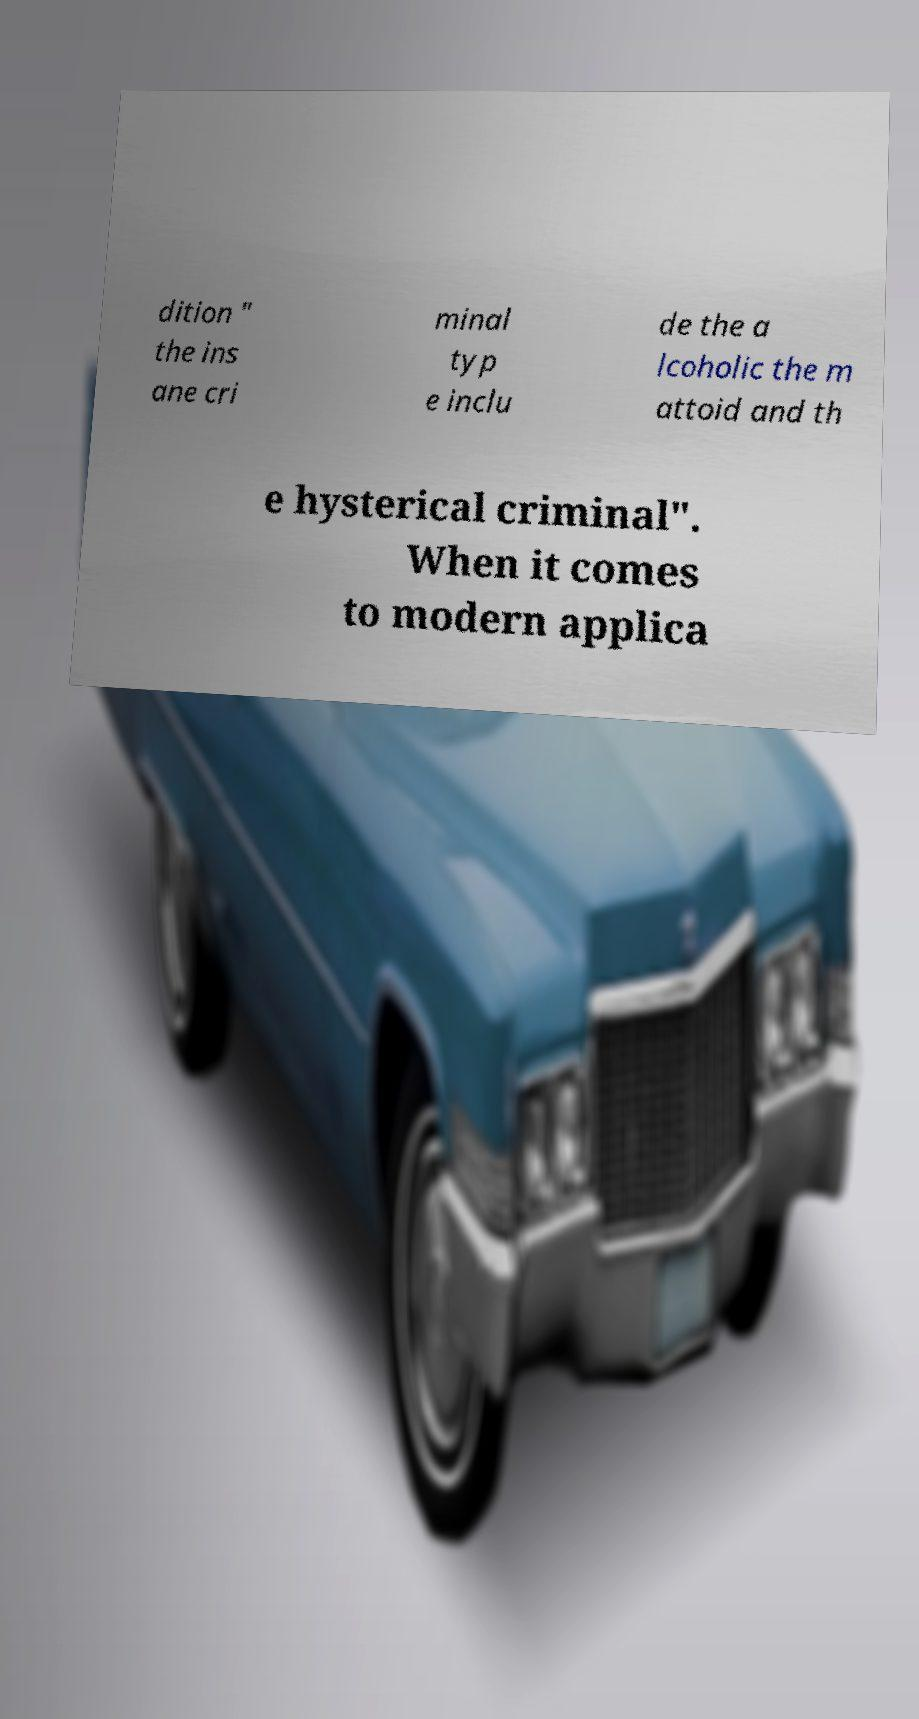I need the written content from this picture converted into text. Can you do that? dition " the ins ane cri minal typ e inclu de the a lcoholic the m attoid and th e hysterical criminal". When it comes to modern applica 